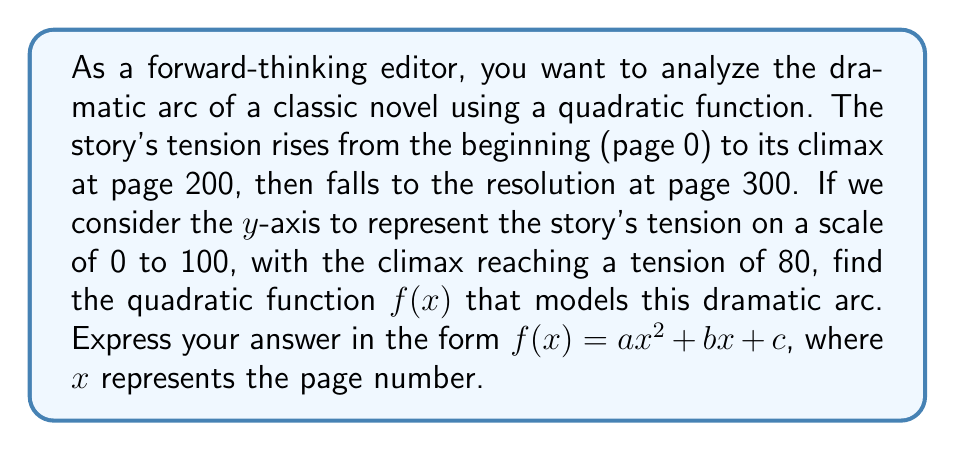Give your solution to this math problem. To find the quadratic function that models the dramatic arc, we need to use the general form of a quadratic function: $f(x) = ax^2 + bx + c$. We have three points that we can use to determine the values of $a$, $b$, and $c$:

1. Beginning: $(0, 0)$
2. Climax: $(200, 80)$
3. Resolution: $(300, 0)$

Let's follow these steps:

1) First, we can use the vertex form of a quadratic function: $f(x) = a(x - h)^2 + k$, where $(h, k)$ is the vertex.

2) The vertex of our parabola is at the climax: $(200, 80)$. So $h = 200$ and $k = 80$.

3) Substituting these into the vertex form:
   $f(x) = a(x - 200)^2 + 80$

4) Now we can use the resolution point $(300, 0)$ to find $a$:
   $0 = a(300 - 200)^2 + 80$
   $0 = a(100)^2 + 80$
   $-80 = 10000a$
   $a = -\frac{80}{10000} = -\frac{1}{125} = -0.008$

5) Now we have the complete function in vertex form:
   $f(x) = -\frac{1}{125}(x - 200)^2 + 80$

6) To convert this to standard form $f(x) = ax^2 + bx + c$, we expand:
   $f(x) = -\frac{1}{125}(x^2 - 400x + 40000) + 80$
   $f(x) = -\frac{1}{125}x^2 + \frac{400}{125}x - \frac{40000}{125} + 80$
   $f(x) = -0.008x^2 + 3.2x - 320 + 80$
   $f(x) = -0.008x^2 + 3.2x - 240$

Therefore, the quadratic function modeling the dramatic arc is $f(x) = -0.008x^2 + 3.2x - 240$.
Answer: $f(x) = -0.008x^2 + 3.2x - 240$ 